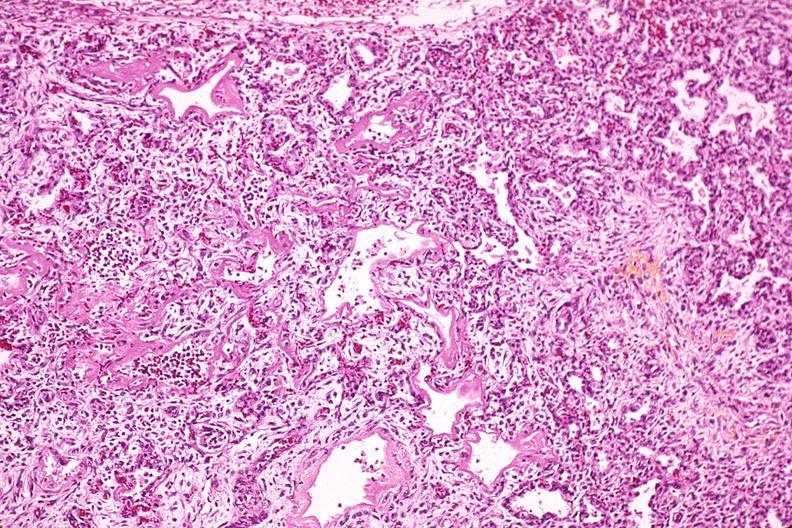why does this image show lung, hyaline membrane disease, yellow discoloration?
Answer the question using a single word or phrase. Due to hyperbilirubinemia 